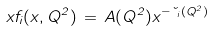<formula> <loc_0><loc_0><loc_500><loc_500>x f _ { i } ( x , Q ^ { 2 } ) \, = \, A ( Q ^ { 2 } ) x ^ { - \lambda _ { i } ( Q ^ { 2 } ) }</formula> 